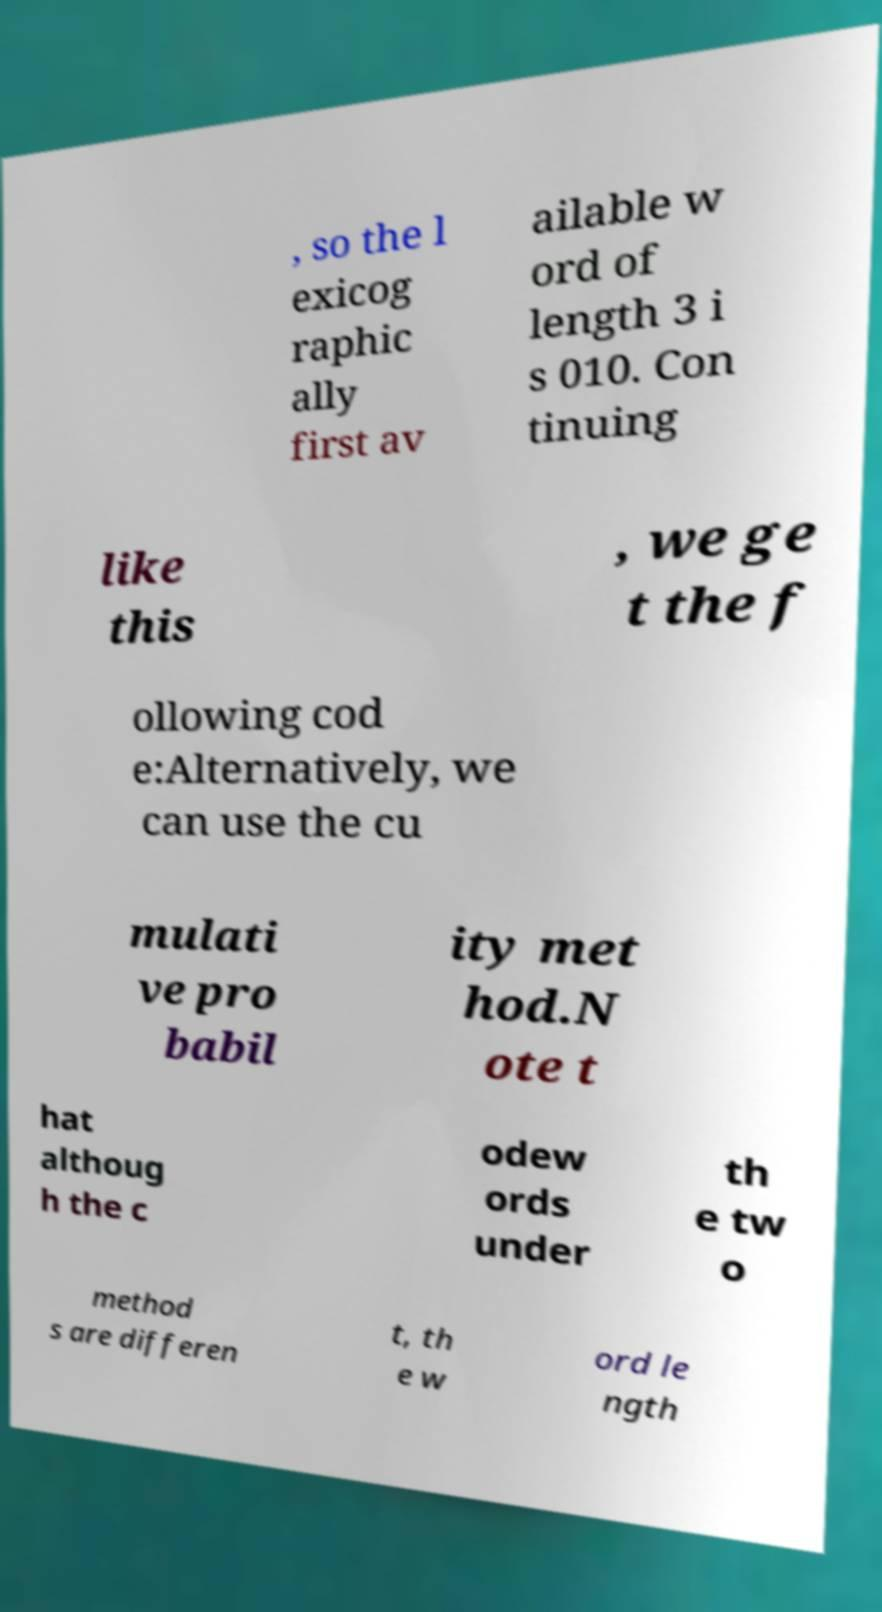There's text embedded in this image that I need extracted. Can you transcribe it verbatim? , so the l exicog raphic ally first av ailable w ord of length 3 i s 010. Con tinuing like this , we ge t the f ollowing cod e:Alternatively, we can use the cu mulati ve pro babil ity met hod.N ote t hat althoug h the c odew ords under th e tw o method s are differen t, th e w ord le ngth 